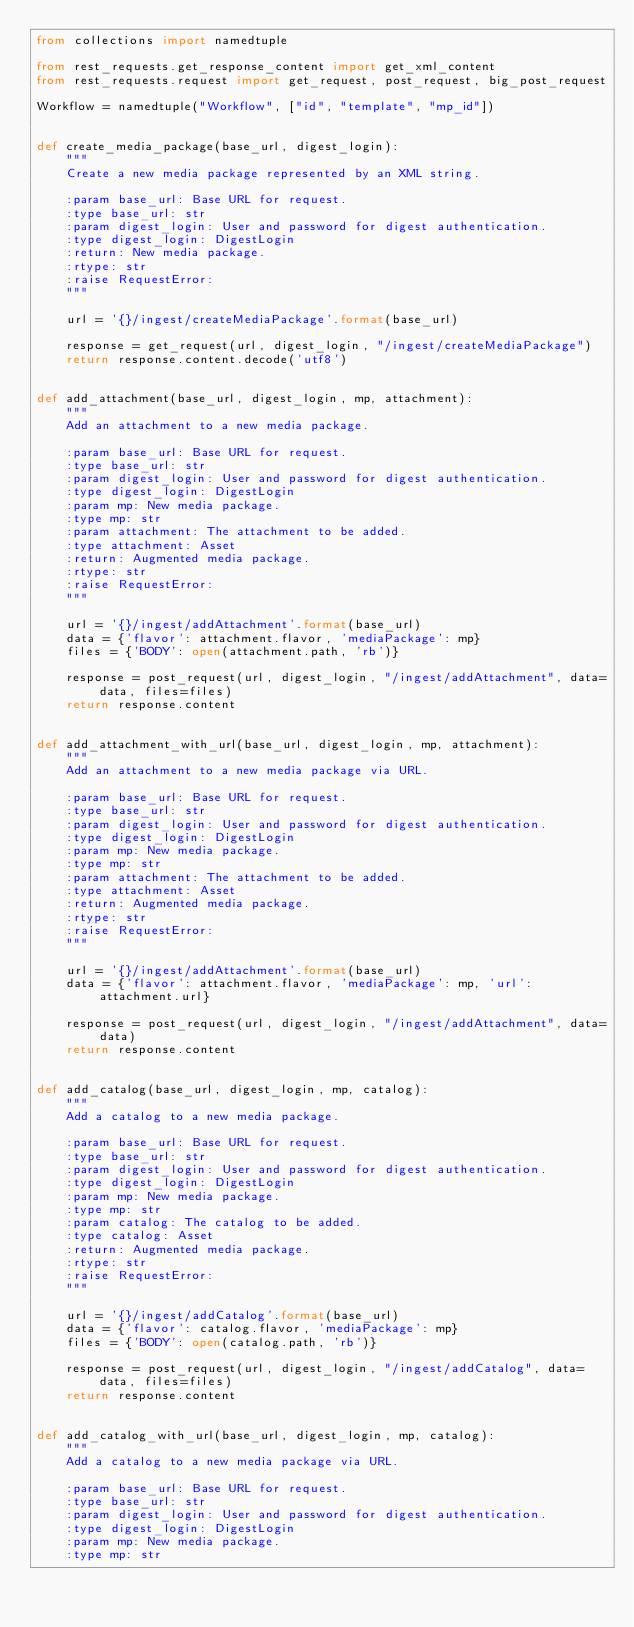<code> <loc_0><loc_0><loc_500><loc_500><_Python_>from collections import namedtuple

from rest_requests.get_response_content import get_xml_content
from rest_requests.request import get_request, post_request, big_post_request

Workflow = namedtuple("Workflow", ["id", "template", "mp_id"])


def create_media_package(base_url, digest_login):
    """
    Create a new media package represented by an XML string.

    :param base_url: Base URL for request.
    :type base_url: str
    :param digest_login: User and password for digest authentication.
    :type digest_login: DigestLogin
    :return: New media package.
    :rtype: str
    :raise RequestError:
    """

    url = '{}/ingest/createMediaPackage'.format(base_url)

    response = get_request(url, digest_login, "/ingest/createMediaPackage")
    return response.content.decode('utf8')


def add_attachment(base_url, digest_login, mp, attachment):
    """
    Add an attachment to a new media package.

    :param base_url: Base URL for request.
    :type base_url: str
    :param digest_login: User and password for digest authentication.
    :type digest_login: DigestLogin
    :param mp: New media package.
    :type mp: str
    :param attachment: The attachment to be added.
    :type attachment: Asset
    :return: Augmented media package.
    :rtype: str
    :raise RequestError:
    """

    url = '{}/ingest/addAttachment'.format(base_url)
    data = {'flavor': attachment.flavor, 'mediaPackage': mp}
    files = {'BODY': open(attachment.path, 'rb')}

    response = post_request(url, digest_login, "/ingest/addAttachment", data=data, files=files)
    return response.content


def add_attachment_with_url(base_url, digest_login, mp, attachment):
    """
    Add an attachment to a new media package via URL.

    :param base_url: Base URL for request.
    :type base_url: str
    :param digest_login: User and password for digest authentication.
    :type digest_login: DigestLogin
    :param mp: New media package.
    :type mp: str
    :param attachment: The attachment to be added.
    :type attachment: Asset
    :return: Augmented media package.
    :rtype: str
    :raise RequestError:
    """

    url = '{}/ingest/addAttachment'.format(base_url)
    data = {'flavor': attachment.flavor, 'mediaPackage': mp, 'url': attachment.url}

    response = post_request(url, digest_login, "/ingest/addAttachment", data=data)
    return response.content


def add_catalog(base_url, digest_login, mp, catalog):
    """
    Add a catalog to a new media package.

    :param base_url: Base URL for request.
    :type base_url: str
    :param digest_login: User and password for digest authentication.
    :type digest_login: DigestLogin
    :param mp: New media package.
    :type mp: str
    :param catalog: The catalog to be added.
    :type catalog: Asset
    :return: Augmented media package.
    :rtype: str
    :raise RequestError:
    """

    url = '{}/ingest/addCatalog'.format(base_url)
    data = {'flavor': catalog.flavor, 'mediaPackage': mp}
    files = {'BODY': open(catalog.path, 'rb')}

    response = post_request(url, digest_login, "/ingest/addCatalog", data=data, files=files)
    return response.content


def add_catalog_with_url(base_url, digest_login, mp, catalog):
    """
    Add a catalog to a new media package via URL.

    :param base_url: Base URL for request.
    :type base_url: str
    :param digest_login: User and password for digest authentication.
    :type digest_login: DigestLogin
    :param mp: New media package.
    :type mp: str</code> 